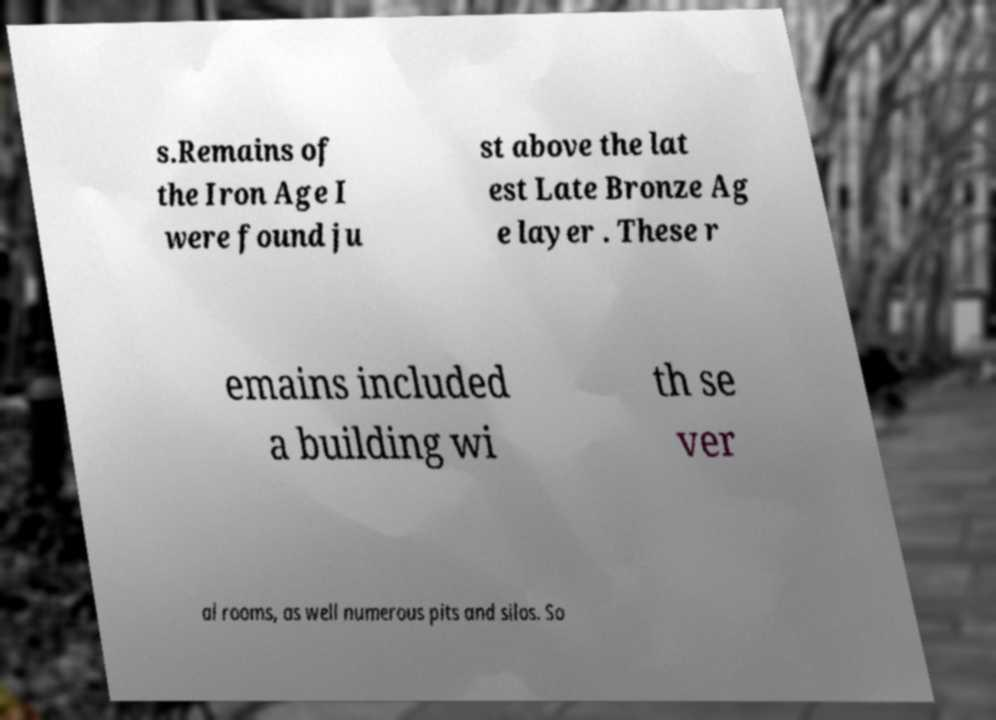Can you accurately transcribe the text from the provided image for me? s.Remains of the Iron Age I were found ju st above the lat est Late Bronze Ag e layer . These r emains included a building wi th se ver al rooms, as well numerous pits and silos. So 